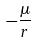<formula> <loc_0><loc_0><loc_500><loc_500>- \frac { \mu } { r }</formula> 